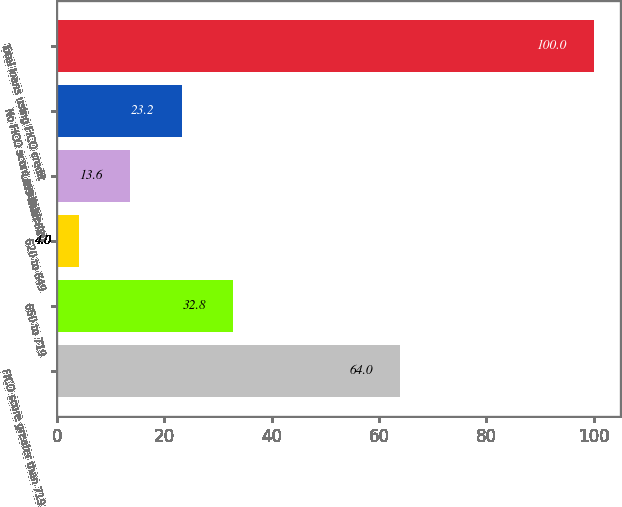Convert chart. <chart><loc_0><loc_0><loc_500><loc_500><bar_chart><fcel>FICO score greater than 719<fcel>650 to 719<fcel>620 to 649<fcel>Less than 620<fcel>No FICO score available or<fcel>Total loans using FICO credit<nl><fcel>64<fcel>32.8<fcel>4<fcel>13.6<fcel>23.2<fcel>100<nl></chart> 